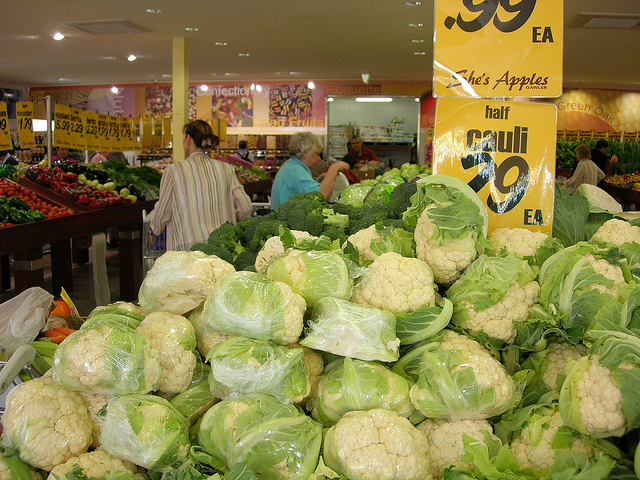Extract all visible text content from this image. cauli EA EA half Fruits 79 Oak Green Apples .99 She's Nul 179 179 179 225 229 179 9 